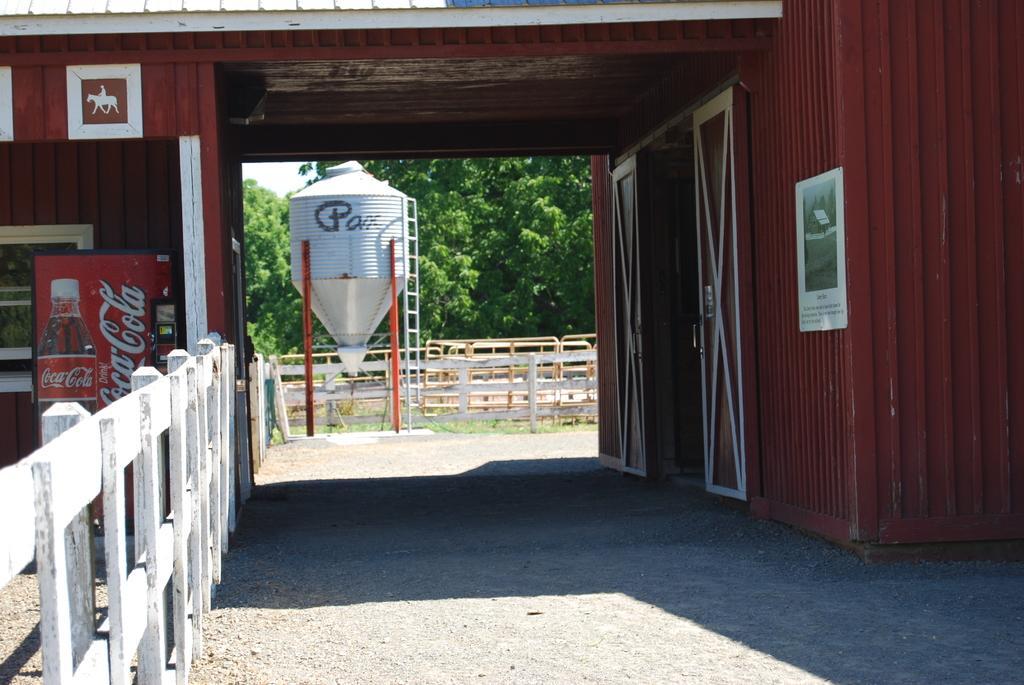Describe this image in one or two sentences. In this image we can see a building, on the building, we can see a poster, there is a refrigerator and a tank, also we can see the doors, fence and trees. 